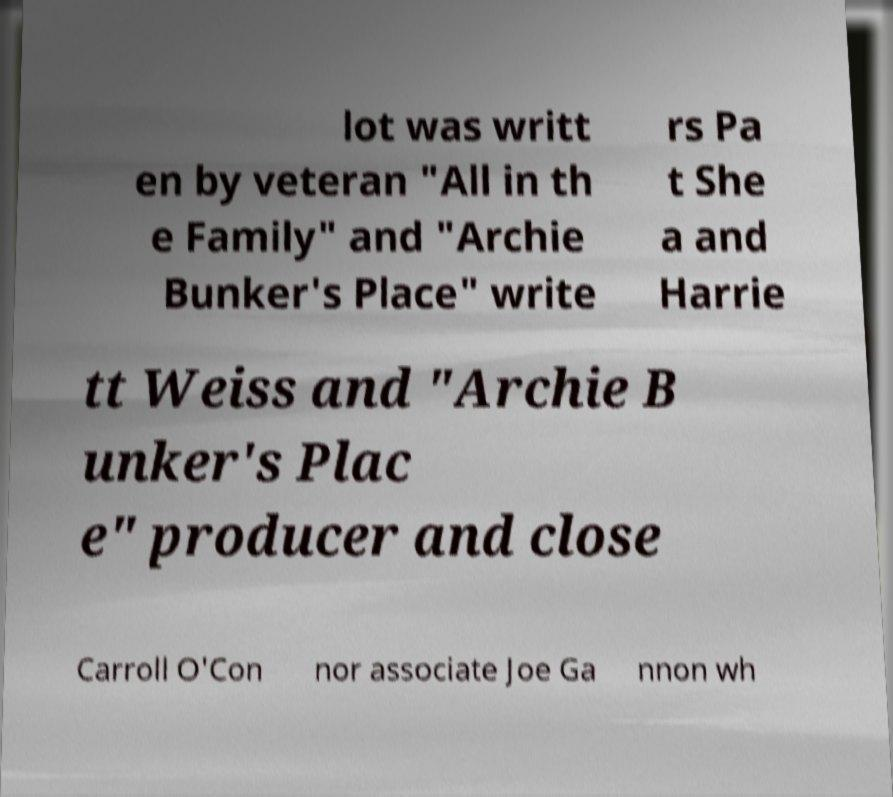Can you accurately transcribe the text from the provided image for me? lot was writt en by veteran "All in th e Family" and "Archie Bunker's Place" write rs Pa t She a and Harrie tt Weiss and "Archie B unker's Plac e" producer and close Carroll O'Con nor associate Joe Ga nnon wh 